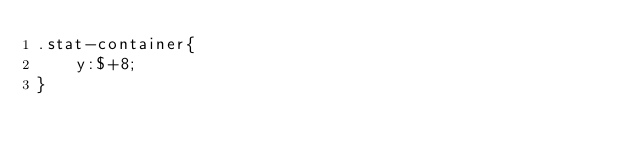Convert code to text. <code><loc_0><loc_0><loc_500><loc_500><_CSS_>.stat-container{
    y:$+8;
}</code> 